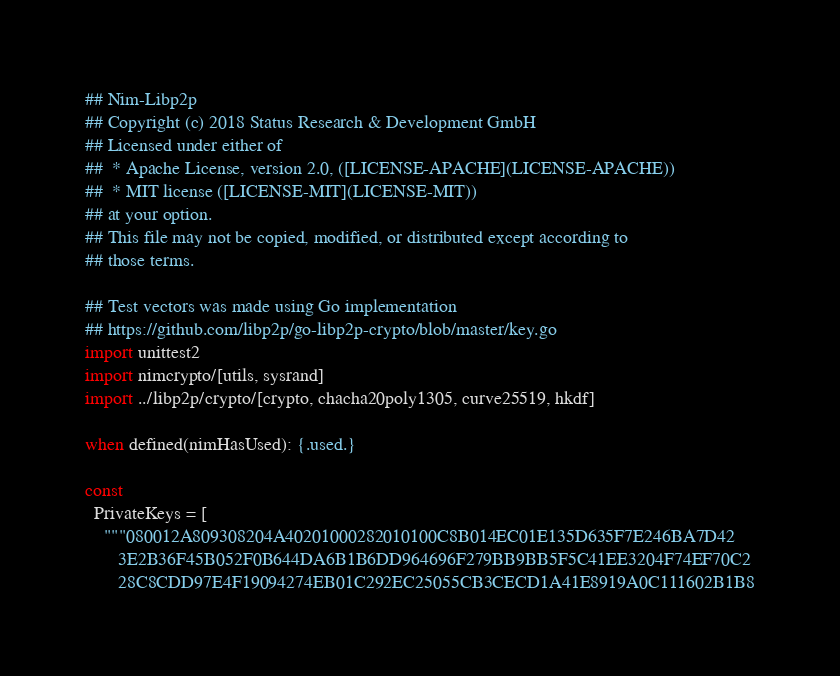Convert code to text. <code><loc_0><loc_0><loc_500><loc_500><_Nim_>## Nim-Libp2p
## Copyright (c) 2018 Status Research & Development GmbH
## Licensed under either of
##  * Apache License, version 2.0, ([LICENSE-APACHE](LICENSE-APACHE))
##  * MIT license ([LICENSE-MIT](LICENSE-MIT))
## at your option.
## This file may not be copied, modified, or distributed except according to
## those terms.

## Test vectors was made using Go implementation
## https://github.com/libp2p/go-libp2p-crypto/blob/master/key.go
import unittest2
import nimcrypto/[utils, sysrand]
import ../libp2p/crypto/[crypto, chacha20poly1305, curve25519, hkdf]

when defined(nimHasUsed): {.used.}

const
  PrivateKeys = [
    """080012A809308204A40201000282010100C8B014EC01E135D635F7E246BA7D42
       3E2B36F45B052F0B644DA6B1B6DD964696F279BB9BB5F5C41EE3204F74EF70C2
       28C8CDD97E4F19094274EB01C292EC25055CB3CECD1A41E8919A0C111602B1B8</code> 